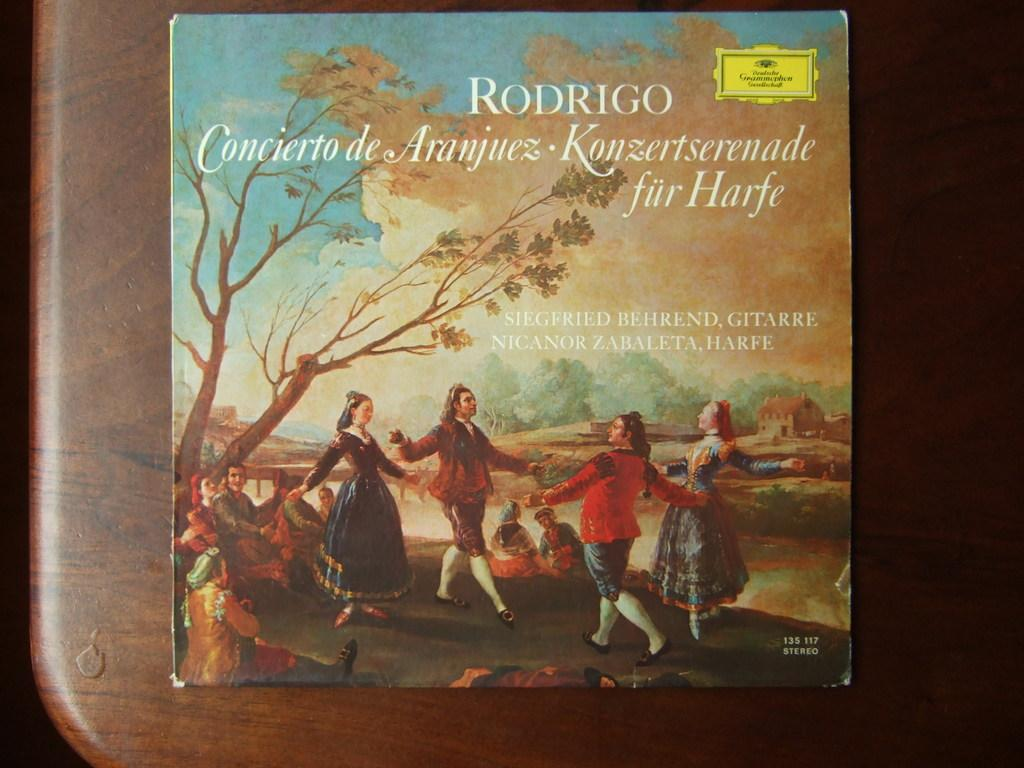<image>
Create a compact narrative representing the image presented. A record for the artist Rodrigo sits on a table. 